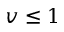Convert formula to latex. <formula><loc_0><loc_0><loc_500><loc_500>v \leq 1</formula> 